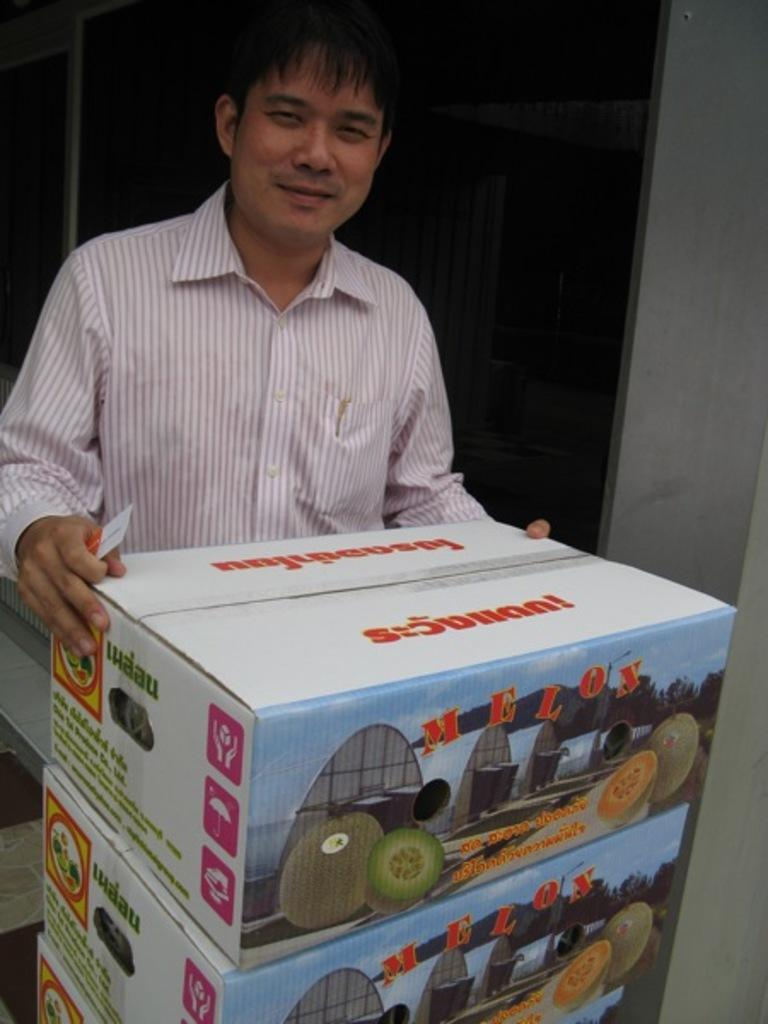<image>
Write a terse but informative summary of the picture. A man holding the top of three boxes containing melons from iuaau. 